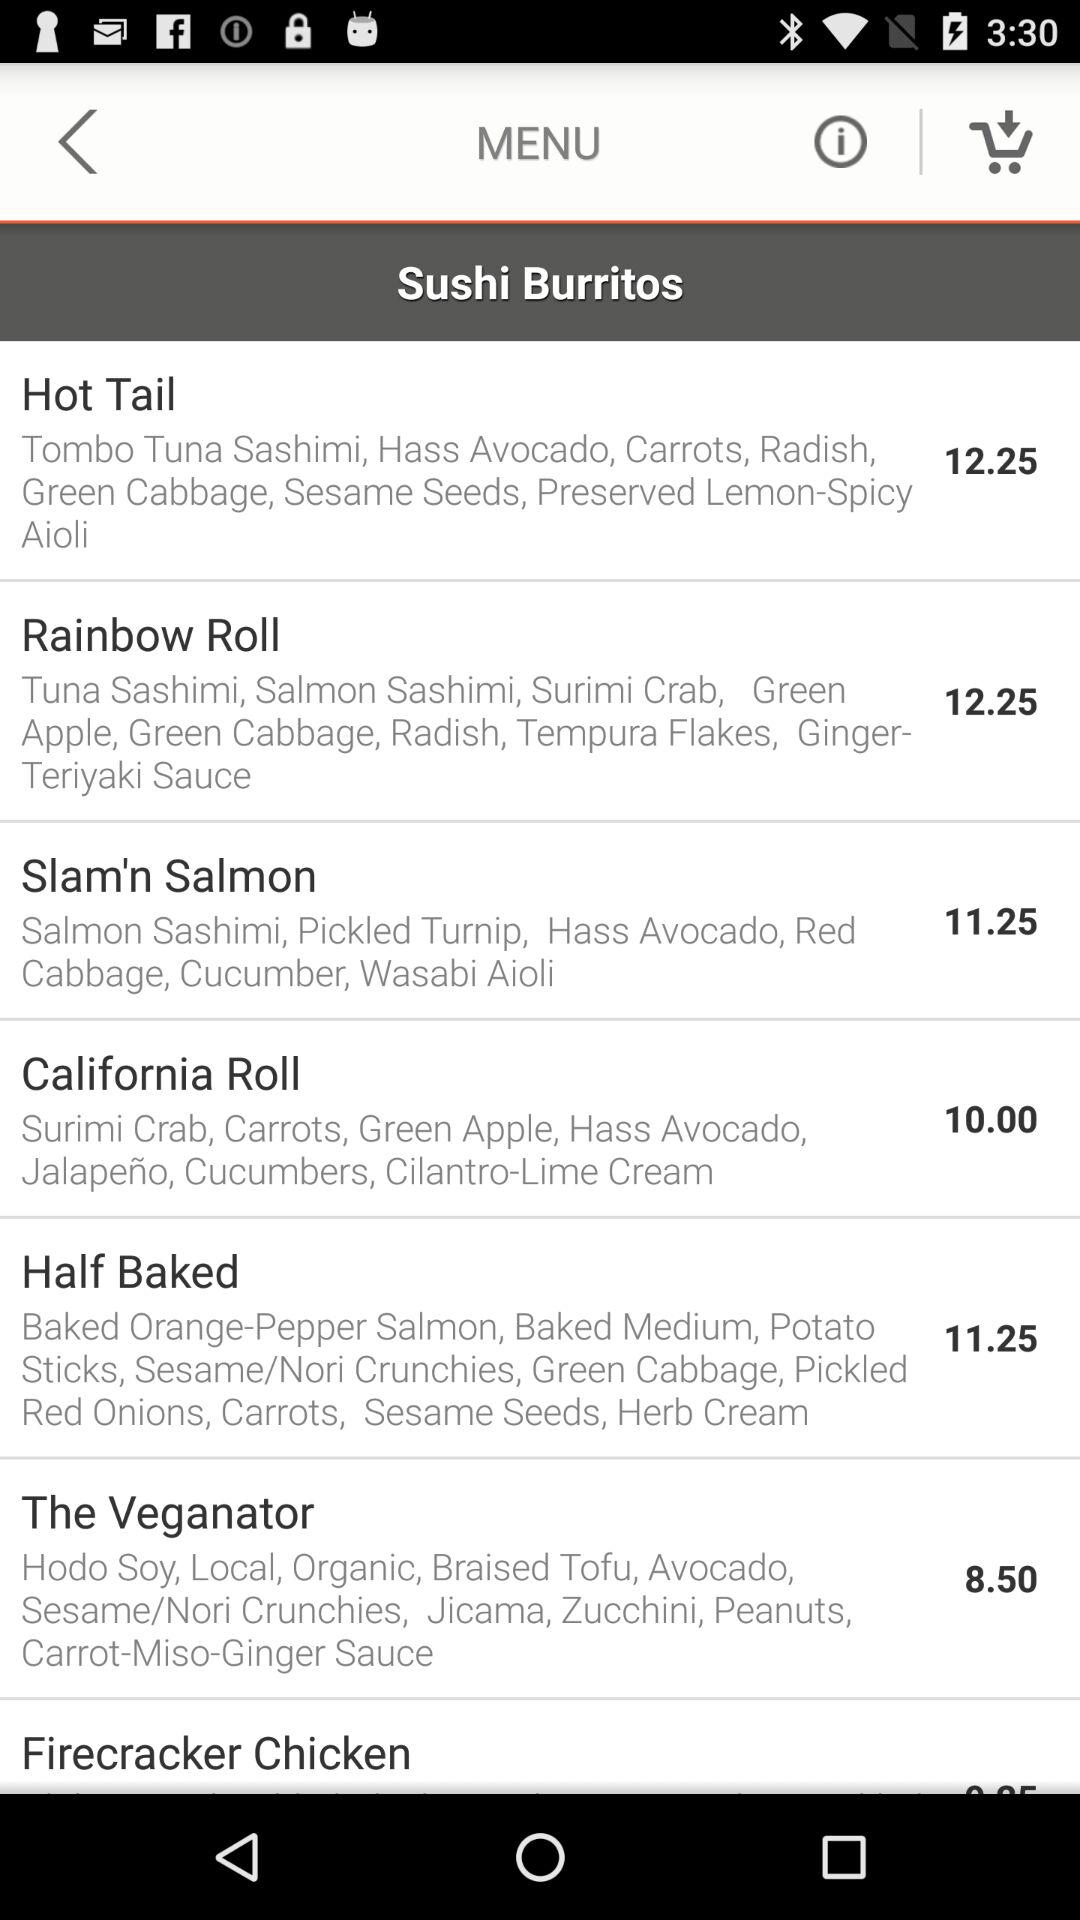How many items are in the cart?
When the provided information is insufficient, respond with <no answer>. <no answer> 